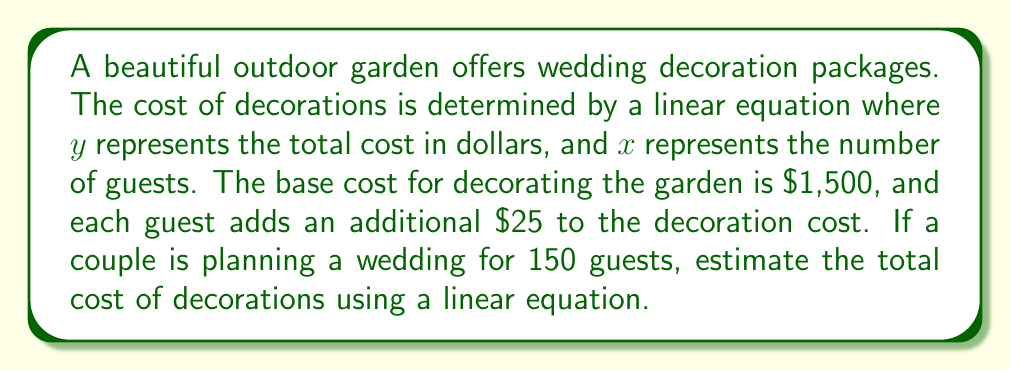Show me your answer to this math problem. Let's approach this step-by-step:

1) We need to form a linear equation based on the given information:
   - The base cost is $1,500
   - Each guest adds $25 to the cost
   - $y$ represents the total cost
   - $x$ represents the number of guests

2) The linear equation will be in the form:
   $$y = mx + b$$
   where $m$ is the slope (cost per guest) and $b$ is the y-intercept (base cost)

3) Plugging in our values:
   $$y = 25x + 1500$$

4) Now, we need to find $y$ when $x = 150$ (for 150 guests):
   $$y = 25(150) + 1500$$

5) Let's solve this equation:
   $$y = 3750 + 1500$$
   $$y = 5250$$

Therefore, the estimated cost of decorations for a wedding with 150 guests is $5,250.
Answer: $5,250 